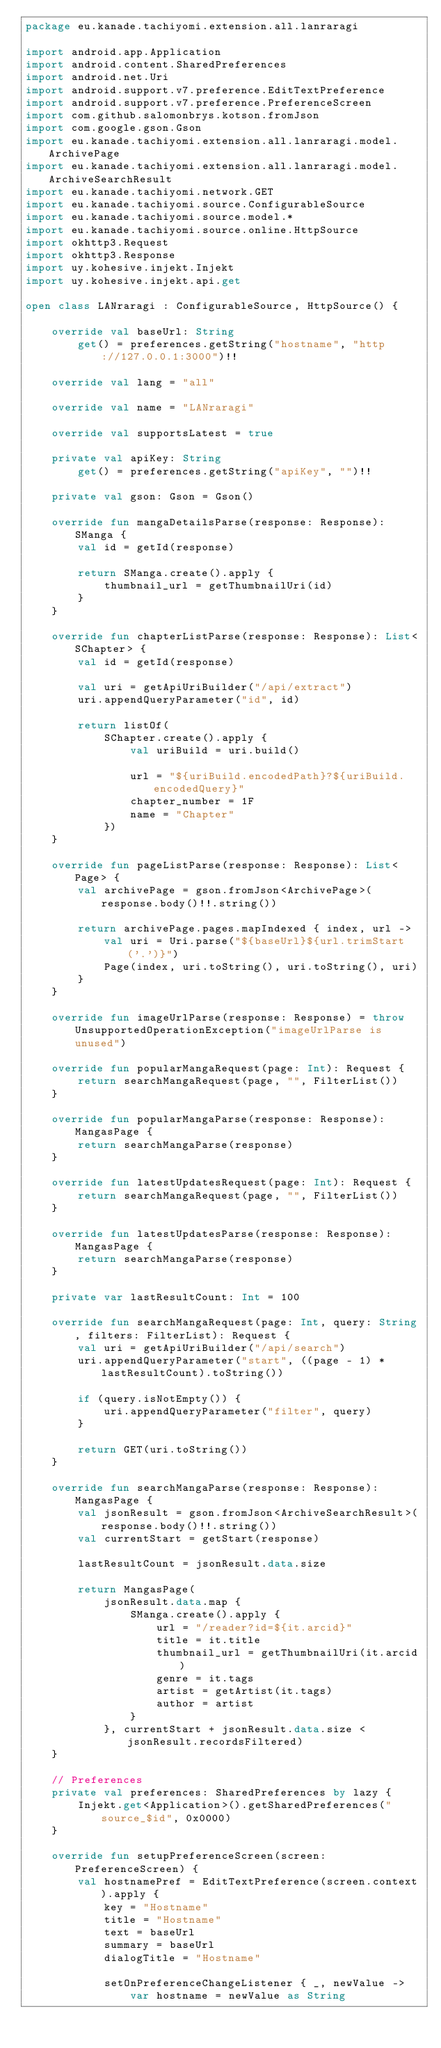Convert code to text. <code><loc_0><loc_0><loc_500><loc_500><_Kotlin_>package eu.kanade.tachiyomi.extension.all.lanraragi

import android.app.Application
import android.content.SharedPreferences
import android.net.Uri
import android.support.v7.preference.EditTextPreference
import android.support.v7.preference.PreferenceScreen
import com.github.salomonbrys.kotson.fromJson
import com.google.gson.Gson
import eu.kanade.tachiyomi.extension.all.lanraragi.model.ArchivePage
import eu.kanade.tachiyomi.extension.all.lanraragi.model.ArchiveSearchResult
import eu.kanade.tachiyomi.network.GET
import eu.kanade.tachiyomi.source.ConfigurableSource
import eu.kanade.tachiyomi.source.model.*
import eu.kanade.tachiyomi.source.online.HttpSource
import okhttp3.Request
import okhttp3.Response
import uy.kohesive.injekt.Injekt
import uy.kohesive.injekt.api.get

open class LANraragi : ConfigurableSource, HttpSource() {

    override val baseUrl: String
        get() = preferences.getString("hostname", "http://127.0.0.1:3000")!!

    override val lang = "all"

    override val name = "LANraragi"

    override val supportsLatest = true

    private val apiKey: String
        get() = preferences.getString("apiKey", "")!!

    private val gson: Gson = Gson()

    override fun mangaDetailsParse(response: Response): SManga {
        val id = getId(response)

        return SManga.create().apply {
            thumbnail_url = getThumbnailUri(id)
        }
    }

    override fun chapterListParse(response: Response): List<SChapter> {
        val id = getId(response)

        val uri = getApiUriBuilder("/api/extract")
        uri.appendQueryParameter("id", id)

        return listOf(
            SChapter.create().apply {
                val uriBuild = uri.build()

                url = "${uriBuild.encodedPath}?${uriBuild.encodedQuery}"
                chapter_number = 1F
                name = "Chapter"
            })
    }

    override fun pageListParse(response: Response): List<Page> {
        val archivePage = gson.fromJson<ArchivePage>(response.body()!!.string())

        return archivePage.pages.mapIndexed { index, url ->
            val uri = Uri.parse("${baseUrl}${url.trimStart('.')}")
            Page(index, uri.toString(), uri.toString(), uri)
        }
    }

    override fun imageUrlParse(response: Response) = throw UnsupportedOperationException("imageUrlParse is unused")

    override fun popularMangaRequest(page: Int): Request {
        return searchMangaRequest(page, "", FilterList())
    }

    override fun popularMangaParse(response: Response): MangasPage {
        return searchMangaParse(response)
    }

    override fun latestUpdatesRequest(page: Int): Request {
        return searchMangaRequest(page, "", FilterList())
    }

    override fun latestUpdatesParse(response: Response): MangasPage {
        return searchMangaParse(response)
    }

    private var lastResultCount: Int = 100

    override fun searchMangaRequest(page: Int, query: String, filters: FilterList): Request {
        val uri = getApiUriBuilder("/api/search")
        uri.appendQueryParameter("start", ((page - 1) * lastResultCount).toString())

        if (query.isNotEmpty()) {
            uri.appendQueryParameter("filter", query)
        }

        return GET(uri.toString())
    }

    override fun searchMangaParse(response: Response): MangasPage {
        val jsonResult = gson.fromJson<ArchiveSearchResult>(response.body()!!.string())
        val currentStart = getStart(response)

        lastResultCount = jsonResult.data.size

        return MangasPage(
            jsonResult.data.map {
                SManga.create().apply {
                    url = "/reader?id=${it.arcid}"
                    title = it.title
                    thumbnail_url = getThumbnailUri(it.arcid)
                    genre = it.tags
                    artist = getArtist(it.tags)
                    author = artist
                }
            }, currentStart + jsonResult.data.size < jsonResult.recordsFiltered)
    }

    // Preferences
    private val preferences: SharedPreferences by lazy {
        Injekt.get<Application>().getSharedPreferences("source_$id", 0x0000)
    }

    override fun setupPreferenceScreen(screen: PreferenceScreen) {
        val hostnamePref = EditTextPreference(screen.context).apply {
            key = "Hostname"
            title = "Hostname"
            text = baseUrl
            summary = baseUrl
            dialogTitle = "Hostname"

            setOnPreferenceChangeListener { _, newValue ->
                var hostname = newValue as String</code> 